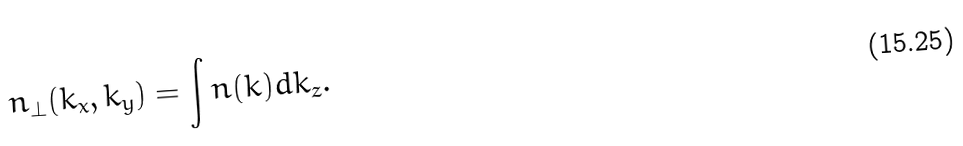<formula> <loc_0><loc_0><loc_500><loc_500>n _ { \perp } ( k _ { x } , k _ { y } ) = \int n ( k ) d k _ { z } .</formula> 